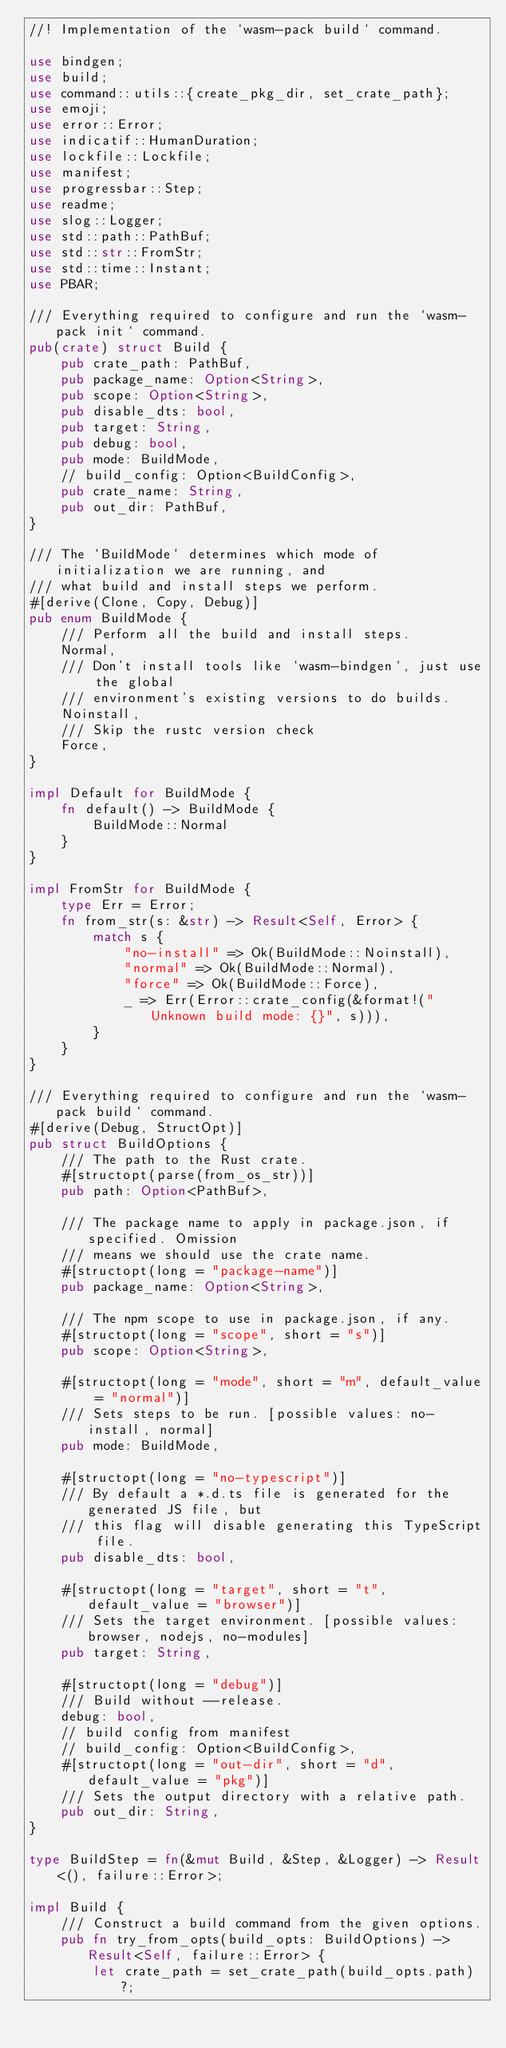<code> <loc_0><loc_0><loc_500><loc_500><_Rust_>//! Implementation of the `wasm-pack build` command.

use bindgen;
use build;
use command::utils::{create_pkg_dir, set_crate_path};
use emoji;
use error::Error;
use indicatif::HumanDuration;
use lockfile::Lockfile;
use manifest;
use progressbar::Step;
use readme;
use slog::Logger;
use std::path::PathBuf;
use std::str::FromStr;
use std::time::Instant;
use PBAR;

/// Everything required to configure and run the `wasm-pack init` command.
pub(crate) struct Build {
    pub crate_path: PathBuf,
    pub package_name: Option<String>,
    pub scope: Option<String>,
    pub disable_dts: bool,
    pub target: String,
    pub debug: bool,
    pub mode: BuildMode,
    // build_config: Option<BuildConfig>,
    pub crate_name: String,
    pub out_dir: PathBuf,
}

/// The `BuildMode` determines which mode of initialization we are running, and
/// what build and install steps we perform.
#[derive(Clone, Copy, Debug)]
pub enum BuildMode {
    /// Perform all the build and install steps.
    Normal,
    /// Don't install tools like `wasm-bindgen`, just use the global
    /// environment's existing versions to do builds.
    Noinstall,
    /// Skip the rustc version check
    Force,
}

impl Default for BuildMode {
    fn default() -> BuildMode {
        BuildMode::Normal
    }
}

impl FromStr for BuildMode {
    type Err = Error;
    fn from_str(s: &str) -> Result<Self, Error> {
        match s {
            "no-install" => Ok(BuildMode::Noinstall),
            "normal" => Ok(BuildMode::Normal),
            "force" => Ok(BuildMode::Force),
            _ => Err(Error::crate_config(&format!("Unknown build mode: {}", s))),
        }
    }
}

/// Everything required to configure and run the `wasm-pack build` command.
#[derive(Debug, StructOpt)]
pub struct BuildOptions {
    /// The path to the Rust crate.
    #[structopt(parse(from_os_str))]
    pub path: Option<PathBuf>,

    /// The package name to apply in package.json, if specified. Omission
    /// means we should use the crate name.
    #[structopt(long = "package-name")]
    pub package_name: Option<String>,

    /// The npm scope to use in package.json, if any.
    #[structopt(long = "scope", short = "s")]
    pub scope: Option<String>,

    #[structopt(long = "mode", short = "m", default_value = "normal")]
    /// Sets steps to be run. [possible values: no-install, normal]
    pub mode: BuildMode,

    #[structopt(long = "no-typescript")]
    /// By default a *.d.ts file is generated for the generated JS file, but
    /// this flag will disable generating this TypeScript file.
    pub disable_dts: bool,

    #[structopt(long = "target", short = "t", default_value = "browser")]
    /// Sets the target environment. [possible values: browser, nodejs, no-modules]
    pub target: String,

    #[structopt(long = "debug")]
    /// Build without --release.
    debug: bool,
    // build config from manifest
    // build_config: Option<BuildConfig>,
    #[structopt(long = "out-dir", short = "d", default_value = "pkg")]
    /// Sets the output directory with a relative path.
    pub out_dir: String,
}

type BuildStep = fn(&mut Build, &Step, &Logger) -> Result<(), failure::Error>;

impl Build {
    /// Construct a build command from the given options.
    pub fn try_from_opts(build_opts: BuildOptions) -> Result<Self, failure::Error> {
        let crate_path = set_crate_path(build_opts.path)?;</code> 